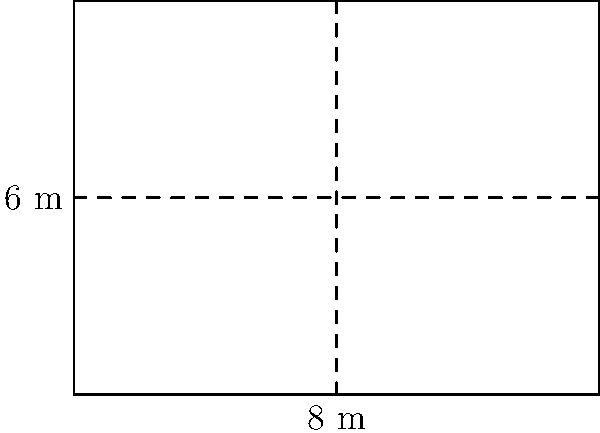During your research on railroad infrastructure, you come across a blueprint of a rectangular train tunnel. The tunnel has a width of 8 meters and a height of 6 meters. What is the cross-sectional area of this tunnel? To find the cross-sectional area of the rectangular train tunnel, we need to follow these steps:

1. Identify the shape: The tunnel's cross-section is a rectangle.

2. Recall the formula for the area of a rectangle:
   Area = length × width

3. In this case:
   - Width of the tunnel = 8 meters
   - Height of the tunnel = 6 meters

4. Apply the formula:
   Area = 8 m × 6 m = 48 m²

5. Interpret the result:
   The cross-sectional area of the tunnel is 48 square meters.

This calculation provides insight into the capacity of the tunnel and helps in understanding the size constraints for trains passing through it, which is crucial information for your historical research on railroad infrastructure.
Answer: 48 m² 